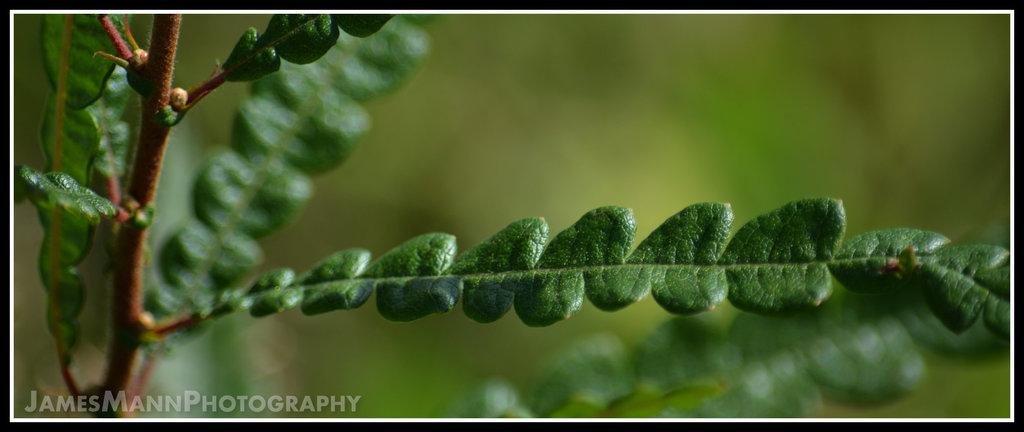What is present in the picture? There is a plant in the picture. What can be observed about the edges of the picture? The picture has a black border. How would you describe the background of the picture? The background of the picture is blurred. Where is the text located in the picture? There is text at the bottom of the picture. What type of tub is visible in the picture? There is no tub present in the picture; it features a plant with a black border and a blurred background. 